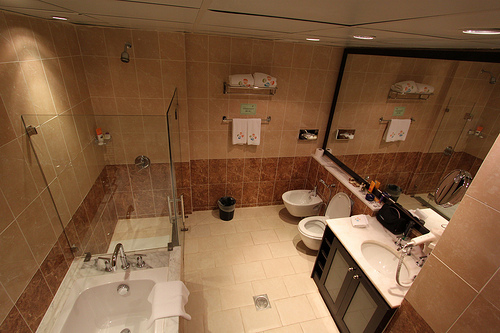How many sinks are in the bathroom? 1 